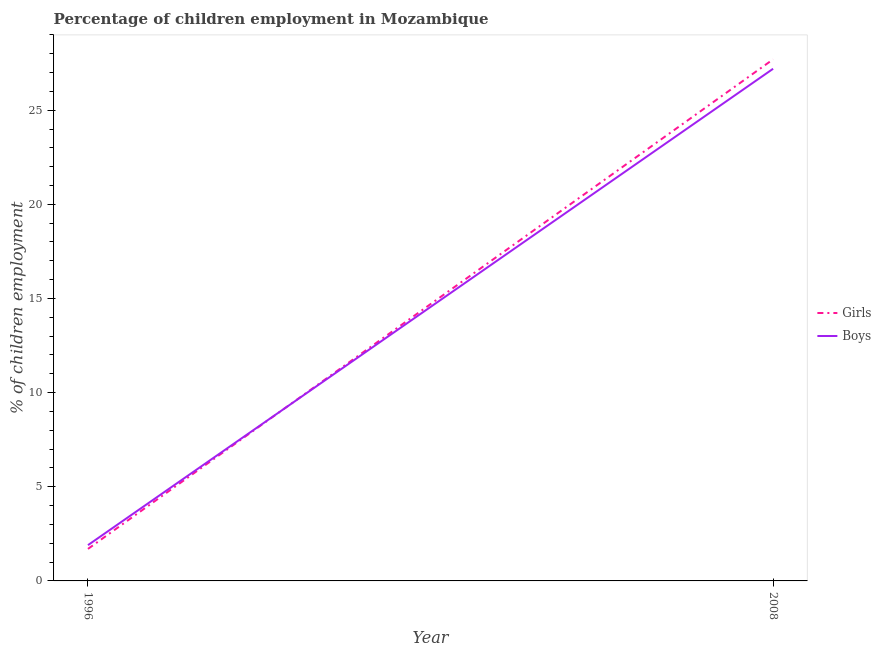How many different coloured lines are there?
Make the answer very short. 2. Does the line corresponding to percentage of employed girls intersect with the line corresponding to percentage of employed boys?
Make the answer very short. Yes. What is the percentage of employed boys in 2008?
Your answer should be compact. 27.2. Across all years, what is the maximum percentage of employed boys?
Your answer should be very brief. 27.2. In which year was the percentage of employed girls maximum?
Your response must be concise. 2008. In which year was the percentage of employed girls minimum?
Give a very brief answer. 1996. What is the total percentage of employed girls in the graph?
Provide a succinct answer. 29.4. What is the difference between the percentage of employed boys in 1996 and that in 2008?
Your answer should be very brief. -25.3. What is the difference between the percentage of employed girls in 1996 and the percentage of employed boys in 2008?
Offer a terse response. -25.5. What is the average percentage of employed boys per year?
Provide a succinct answer. 14.55. In the year 1996, what is the difference between the percentage of employed girls and percentage of employed boys?
Ensure brevity in your answer.  -0.2. What is the ratio of the percentage of employed boys in 1996 to that in 2008?
Ensure brevity in your answer.  0.07. Is the percentage of employed girls in 1996 less than that in 2008?
Make the answer very short. Yes. Is the percentage of employed boys strictly greater than the percentage of employed girls over the years?
Provide a succinct answer. No. How many lines are there?
Offer a terse response. 2. Are the values on the major ticks of Y-axis written in scientific E-notation?
Make the answer very short. No. What is the title of the graph?
Give a very brief answer. Percentage of children employment in Mozambique. Does "Primary education" appear as one of the legend labels in the graph?
Offer a terse response. No. What is the label or title of the Y-axis?
Provide a short and direct response. % of children employment. What is the % of children employment in Girls in 1996?
Provide a succinct answer. 1.7. What is the % of children employment in Boys in 1996?
Ensure brevity in your answer.  1.9. What is the % of children employment in Girls in 2008?
Your answer should be very brief. 27.7. What is the % of children employment of Boys in 2008?
Give a very brief answer. 27.2. Across all years, what is the maximum % of children employment of Girls?
Give a very brief answer. 27.7. Across all years, what is the maximum % of children employment in Boys?
Your answer should be compact. 27.2. Across all years, what is the minimum % of children employment of Girls?
Make the answer very short. 1.7. What is the total % of children employment in Girls in the graph?
Offer a very short reply. 29.4. What is the total % of children employment of Boys in the graph?
Keep it short and to the point. 29.1. What is the difference between the % of children employment of Girls in 1996 and that in 2008?
Ensure brevity in your answer.  -26. What is the difference between the % of children employment of Boys in 1996 and that in 2008?
Make the answer very short. -25.3. What is the difference between the % of children employment in Girls in 1996 and the % of children employment in Boys in 2008?
Offer a very short reply. -25.5. What is the average % of children employment of Girls per year?
Your response must be concise. 14.7. What is the average % of children employment in Boys per year?
Make the answer very short. 14.55. In the year 1996, what is the difference between the % of children employment in Girls and % of children employment in Boys?
Make the answer very short. -0.2. What is the ratio of the % of children employment in Girls in 1996 to that in 2008?
Keep it short and to the point. 0.06. What is the ratio of the % of children employment of Boys in 1996 to that in 2008?
Ensure brevity in your answer.  0.07. What is the difference between the highest and the second highest % of children employment in Boys?
Give a very brief answer. 25.3. What is the difference between the highest and the lowest % of children employment of Girls?
Offer a terse response. 26. What is the difference between the highest and the lowest % of children employment in Boys?
Provide a short and direct response. 25.3. 